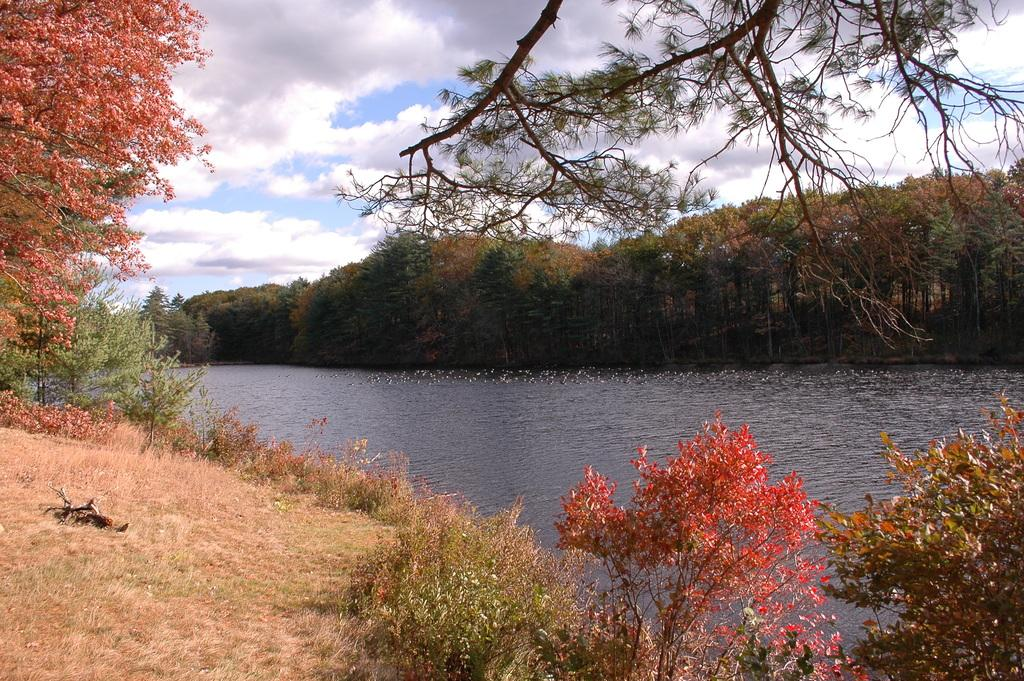What is the main subject in the center of the image? There is water in the center of the image. What can be seen in the background of the image? There is a group of trees in the background. How would you describe the sky in the image? The sky is cloudy. Where is the nut located in the image? There is no nut present in the image. What type of list can be seen in the image? There is no list present in the image. 